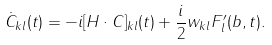<formula> <loc_0><loc_0><loc_500><loc_500>\dot { C } _ { k l } ( t ) = - i [ { H } \cdot { C } ] _ { k l } ( t ) + \frac { i } { 2 } w _ { k l } F _ { l } ^ { \prime } ( b , t ) .</formula> 